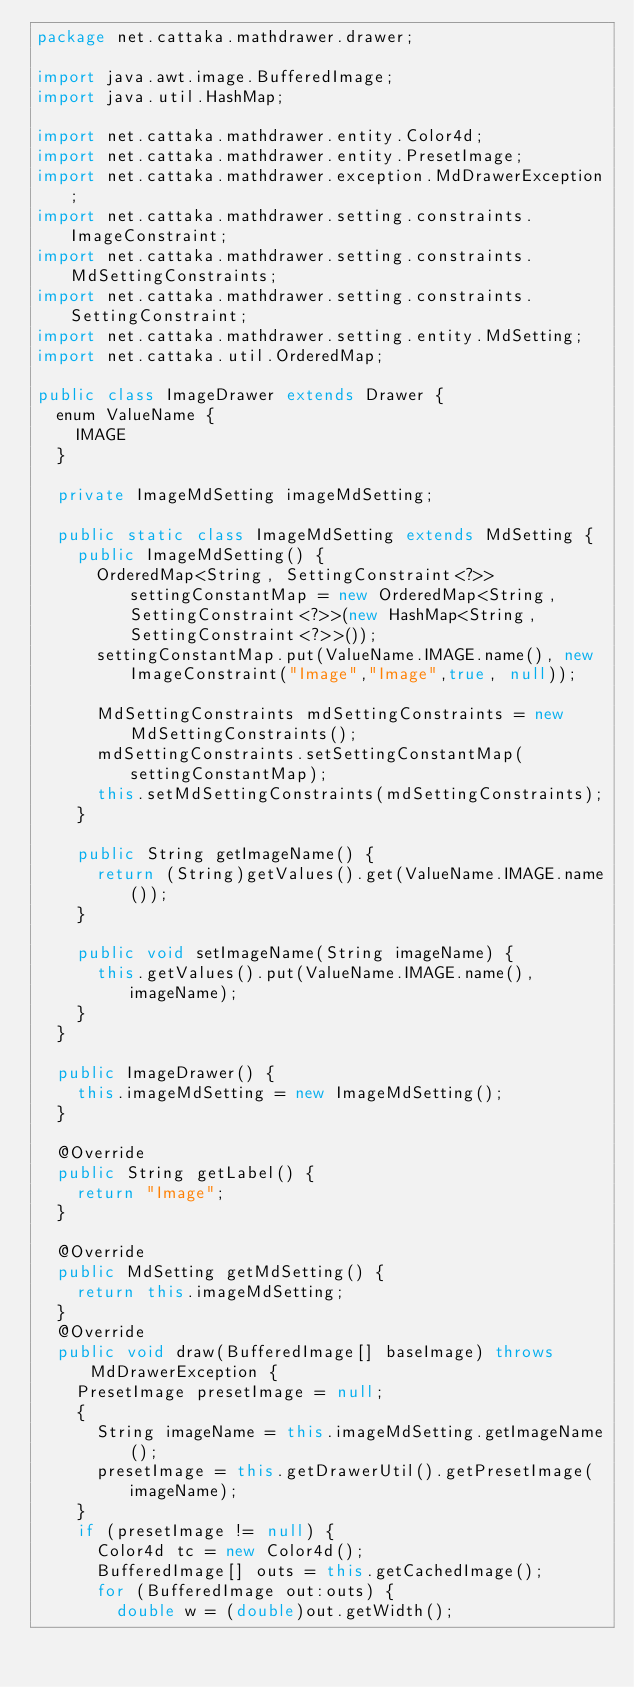<code> <loc_0><loc_0><loc_500><loc_500><_Java_>package net.cattaka.mathdrawer.drawer;

import java.awt.image.BufferedImage;
import java.util.HashMap;

import net.cattaka.mathdrawer.entity.Color4d;
import net.cattaka.mathdrawer.entity.PresetImage;
import net.cattaka.mathdrawer.exception.MdDrawerException;
import net.cattaka.mathdrawer.setting.constraints.ImageConstraint;
import net.cattaka.mathdrawer.setting.constraints.MdSettingConstraints;
import net.cattaka.mathdrawer.setting.constraints.SettingConstraint;
import net.cattaka.mathdrawer.setting.entity.MdSetting;
import net.cattaka.util.OrderedMap;

public class ImageDrawer extends Drawer {
	enum ValueName {
		IMAGE
	}
	
	private ImageMdSetting imageMdSetting;
	
	public static class ImageMdSetting extends MdSetting {
		public ImageMdSetting() {
			OrderedMap<String, SettingConstraint<?>> settingConstantMap = new OrderedMap<String, SettingConstraint<?>>(new HashMap<String, SettingConstraint<?>>());
			settingConstantMap.put(ValueName.IMAGE.name(), new ImageConstraint("Image","Image",true, null));
			
			MdSettingConstraints mdSettingConstraints = new MdSettingConstraints();
			mdSettingConstraints.setSettingConstantMap(settingConstantMap);
			this.setMdSettingConstraints(mdSettingConstraints);
		}
		
		public String getImageName() {
			return (String)getValues().get(ValueName.IMAGE.name());
		}

		public void setImageName(String imageName) {
			this.getValues().put(ValueName.IMAGE.name(), imageName);
		}
	}
	
	public ImageDrawer() {
		this.imageMdSetting = new ImageMdSetting();
	}
	
	@Override
	public String getLabel() {
		return "Image";
	}
	
	@Override
	public MdSetting getMdSetting() {
		return this.imageMdSetting;
	}
	@Override
	public void draw(BufferedImage[] baseImage) throws MdDrawerException {
		PresetImage presetImage = null;
		{
			String imageName = this.imageMdSetting.getImageName();
			presetImage = this.getDrawerUtil().getPresetImage(imageName);
		}
		if (presetImage != null) {
			Color4d tc = new Color4d();
			BufferedImage[] outs = this.getCachedImage();
			for (BufferedImage out:outs) {
				double w = (double)out.getWidth();</code> 